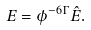<formula> <loc_0><loc_0><loc_500><loc_500>E = \phi ^ { - 6 \Gamma } \hat { E } .</formula> 